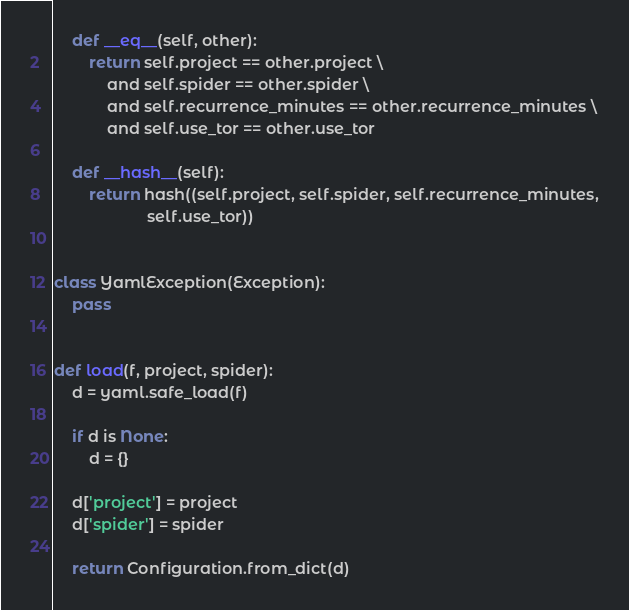Convert code to text. <code><loc_0><loc_0><loc_500><loc_500><_Python_>    def __eq__(self, other):
        return self.project == other.project \
            and self.spider == other.spider \
            and self.recurrence_minutes == other.recurrence_minutes \
            and self.use_tor == other.use_tor

    def __hash__(self):
        return hash((self.project, self.spider, self.recurrence_minutes,
                     self.use_tor))


class YamlException(Exception):
    pass


def load(f, project, spider):
    d = yaml.safe_load(f)

    if d is None:
        d = {}

    d['project'] = project
    d['spider'] = spider

    return Configuration.from_dict(d)
</code> 